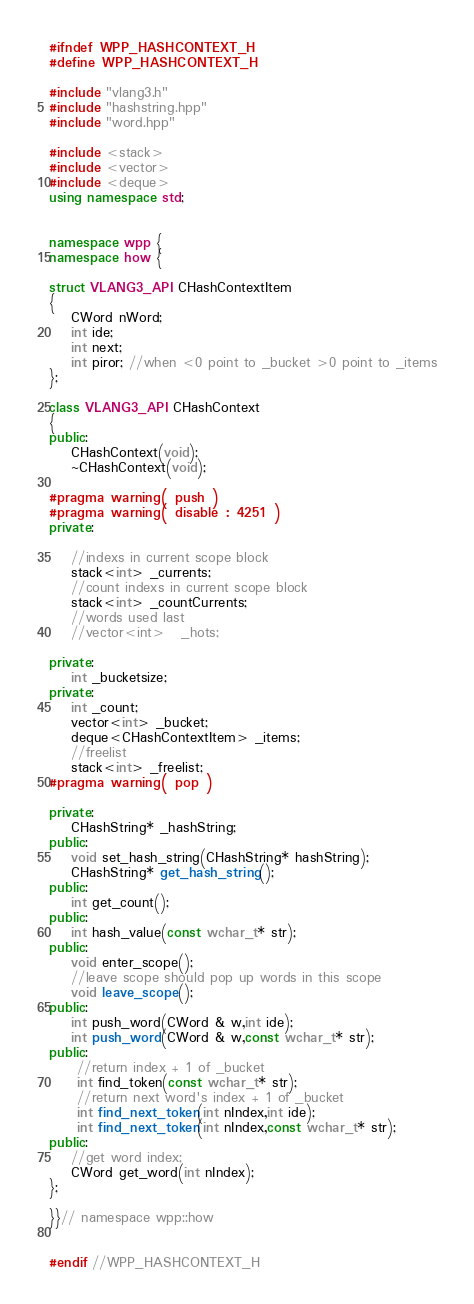<code> <loc_0><loc_0><loc_500><loc_500><_C++_>#ifndef WPP_HASHCONTEXT_H
#define WPP_HASHCONTEXT_H

#include "vlang3.h"
#include "hashstring.hpp"
#include "word.hpp"

#include <stack>
#include <vector>
#include <deque>
using namespace std;


namespace wpp {
namespace how {

struct VLANG3_API CHashContextItem
{
	CWord nWord;
	int ide;
	int next;
	int piror; //when <0 point to _bucket >0 point to _items
};

class VLANG3_API CHashContext
{
public:
	CHashContext(void);
	~CHashContext(void);
 
#pragma warning( push )
#pragma warning( disable : 4251 )
private:

	//indexs in current scope block
	stack<int> _currents;
	//count indexs in current scope block
	stack<int> _countCurrents;
	//words used last
	//vector<int>	_hots;

private:
	int _bucketsize;
private:
	int _count;
	vector<int> _bucket;
	deque<CHashContextItem> _items;
	//freelist
	stack<int> _freelist;
#pragma warning( pop ) 

private:
	CHashString* _hashString;
public:
	void set_hash_string(CHashString* hashString);
	CHashString* get_hash_string();
public:
	int get_count();
public:
	int hash_value(const wchar_t* str);
public:
	void enter_scope();
	//leave scope should pop up words in this scope
	void leave_scope();
public:
	int push_word(CWord & w,int ide);
	int push_word(CWord & w,const wchar_t* str);
public:
	 //return index + 1 of _bucket
	 int find_token(const wchar_t* str);
	 //return next word's index + 1 of _bucket
	 int find_next_token(int nIndex,int ide);
	 int find_next_token(int nIndex,const wchar_t* str);
public:
	//get word index;
	CWord get_word(int nIndex);
};

}}// namespace wpp::how


#endif //WPP_HASHCONTEXT_H</code> 